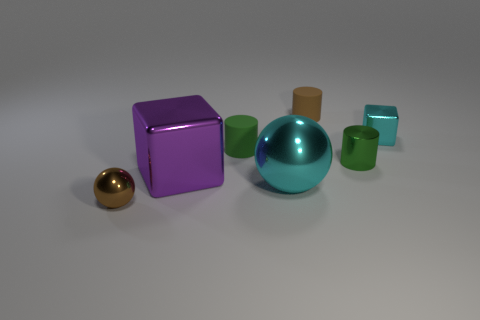What is the shape of the brown object that is made of the same material as the large cyan sphere?
Make the answer very short. Sphere. Are there fewer rubber cylinders that are behind the small green matte object than big cubes to the right of the large cyan thing?
Provide a succinct answer. No. How many large objects are either cubes or purple shiny blocks?
Your response must be concise. 1. There is a rubber object that is behind the small cyan metal object; does it have the same shape as the matte thing in front of the tiny cyan object?
Provide a succinct answer. Yes. There is a sphere right of the metallic ball in front of the big object in front of the large purple block; what size is it?
Your answer should be very brief. Large. There is a cyan shiny thing that is behind the tiny green matte thing; what is its size?
Keep it short and to the point. Small. There is a cube that is on the left side of the tiny cyan metal thing; what is it made of?
Your answer should be very brief. Metal. How many blue things are metallic balls or large things?
Keep it short and to the point. 0. Do the purple block and the green object behind the green shiny object have the same material?
Your answer should be very brief. No. Are there the same number of cyan metallic objects on the right side of the small green metallic object and brown objects that are on the right side of the green rubber cylinder?
Offer a very short reply. Yes. 